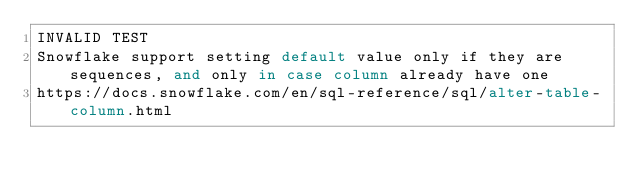<code> <loc_0><loc_0><loc_500><loc_500><_SQL_>INVALID TEST
Snowflake support setting default value only if they are sequences, and only in case column already have one
https://docs.snowflake.com/en/sql-reference/sql/alter-table-column.html</code> 